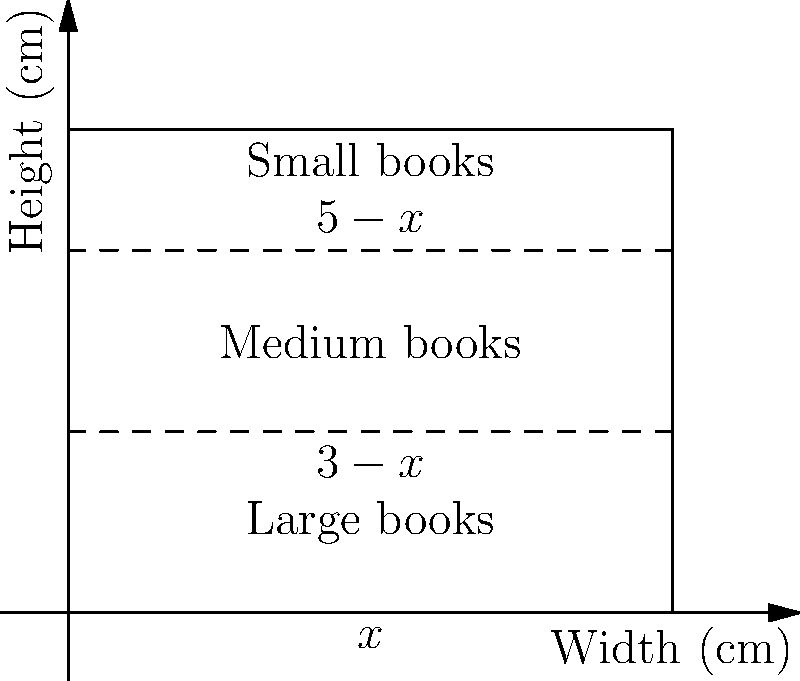As a bookstore owner specializing in rare Eastern European literature, you want to optimize your shelf space. You have a shelf that is 10 cm wide and 8 cm tall. You decide to divide it into three sections: one for large books (bottom), one for medium books (middle), and one for small books (top). The heights of these sections are $x$ cm, $(3-x)$ cm, and $(5-x)$ cm respectively, where $0 < x < 3$. If the number of books that can fit in each section is proportional to its area, what value of $x$ will maximize the total number of books on the shelf? Let's approach this step-by-step:

1) First, we need to express the areas of each section in terms of $x$:
   - Large books section: $A_1 = 10x$
   - Medium books section: $A_2 = 10(3-x) = 30-10x$
   - Small books section: $A_3 = 10(5-x) = 50-10x$

2) The total number of books will be proportional to the sum of these areas. Let's call this sum $A(x)$:
   
   $A(x) = A_1 + A_2 + A_3 = 10x + (30-10x) + (50-10x) = 80-10x$

3) To find the maximum value of $A(x)$, we need to find where its derivative equals zero:
   
   $\frac{dA}{dx} = -10$

4) However, the derivative is constant and negative. This means $A(x)$ is always decreasing as $x$ increases.

5) Since we want to maximize $A(x)$, and it's always decreasing, we should choose the smallest possible value for $x$.

6) The question states that $0 < x < 3$, so the smallest possible value for $x$ is just slightly above 0.

7) Practically, we can't make the large books section infinitesimally small, so we should choose the smallest practical value for $x$.
Answer: $x$ should be as close to 0 as practically possible. 